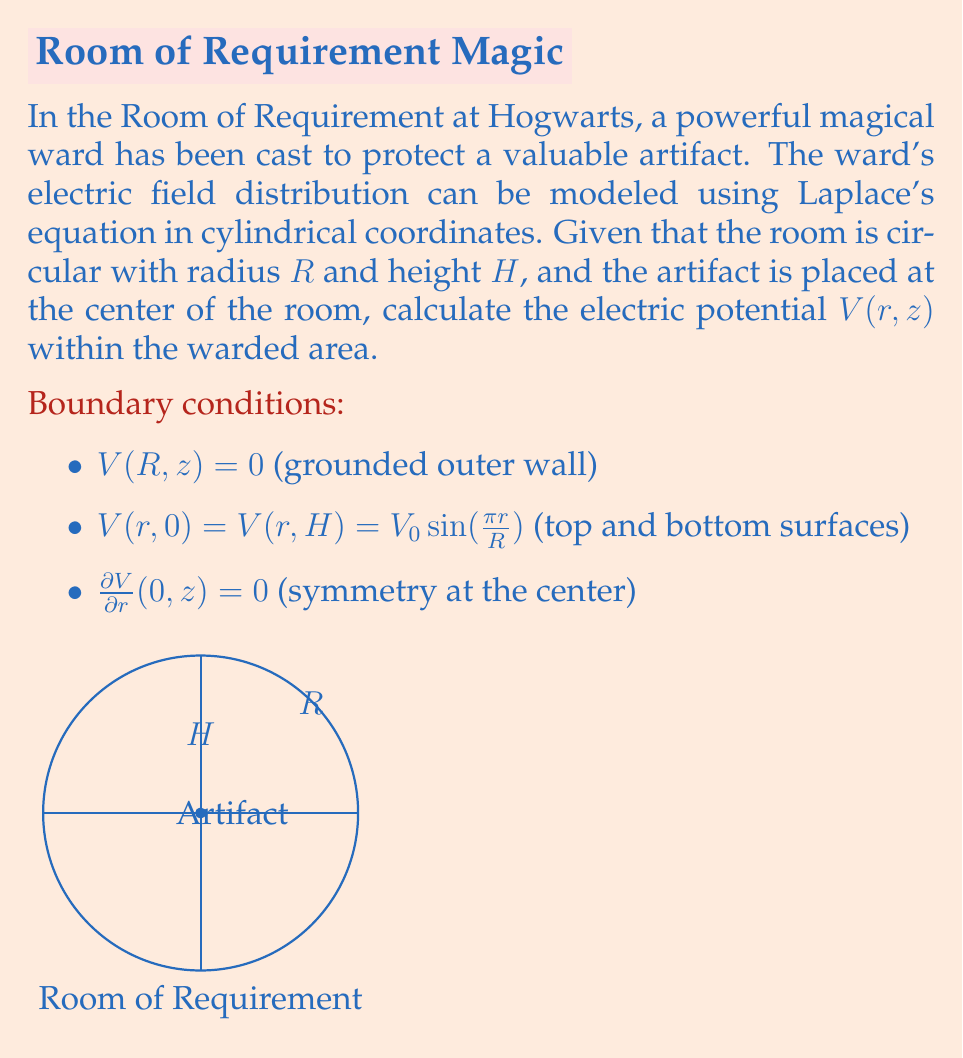Teach me how to tackle this problem. To solve this problem, we'll use the method of separation of variables for Laplace's equation in cylindrical coordinates:

1) Laplace's equation in cylindrical coordinates (assuming azimuthal symmetry):

   $$\frac{1}{r}\frac{\partial}{\partial r}\left(r\frac{\partial V}{\partial r}\right) + \frac{\partial^2 V}{\partial z^2} = 0$$

2) Assume a solution of the form $V(r,z) = R(r)Z(z)$

3) Substituting into Laplace's equation and separating variables:

   $$\frac{1}{r R}\frac{d}{dr}\left(r\frac{dR}{dr}\right) = -\frac{1}{Z}\frac{d^2Z}{dz^2} = k^2$$

4) Solving for $Z(z)$:
   $$Z(z) = A \cosh(kz) + B \sinh(kz)$$

5) Solving for $R(r)$:
   $$R(r) = C J_0(kr) + D Y_0(kr)$$
   where $J_0$ and $Y_0$ are Bessel functions of the first and second kind.

6) Due to symmetry at $r=0$, $D=0$. The general solution is:

   $$V(r,z) = \sum_{n=1}^{\infty} [A_n \cosh(k_n z) + B_n \sinh(k_n z)] J_0(k_n r)$$

7) Applying boundary conditions:
   - $V(R,z) = 0$ implies $J_0(k_n R) = 0$, so $k_n = \frac{\alpha_n}{R}$ where $\alpha_n$ are zeros of $J_0$
   - $V(r,0) = V(r,H) = V_0 \sin(\frac{\pi r}{R})$ implies $k_1 = \frac{\pi}{R}$ and $k_n = 0$ for $n > 1$

8) The final solution is:

   $$V(r,z) = V_0 \frac{\sinh(\pi z/R) + \sinh(\pi(H-z)/R)}{\sinh(\pi H/R)} \sin(\frac{\pi r}{R})$$
Answer: $V(r,z) = V_0 \frac{\sinh(\pi z/R) + \sinh(\pi(H-z)/R)}{\sinh(\pi H/R)} \sin(\frac{\pi r}{R})$ 